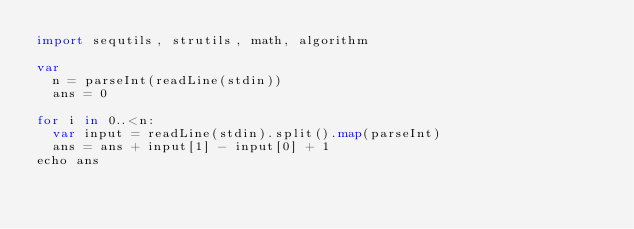<code> <loc_0><loc_0><loc_500><loc_500><_Nim_>import sequtils, strutils, math, algorithm

var
  n = parseInt(readLine(stdin))
  ans = 0

for i in 0..<n:
  var input = readLine(stdin).split().map(parseInt)
  ans = ans + input[1] - input[0] + 1
echo ans</code> 